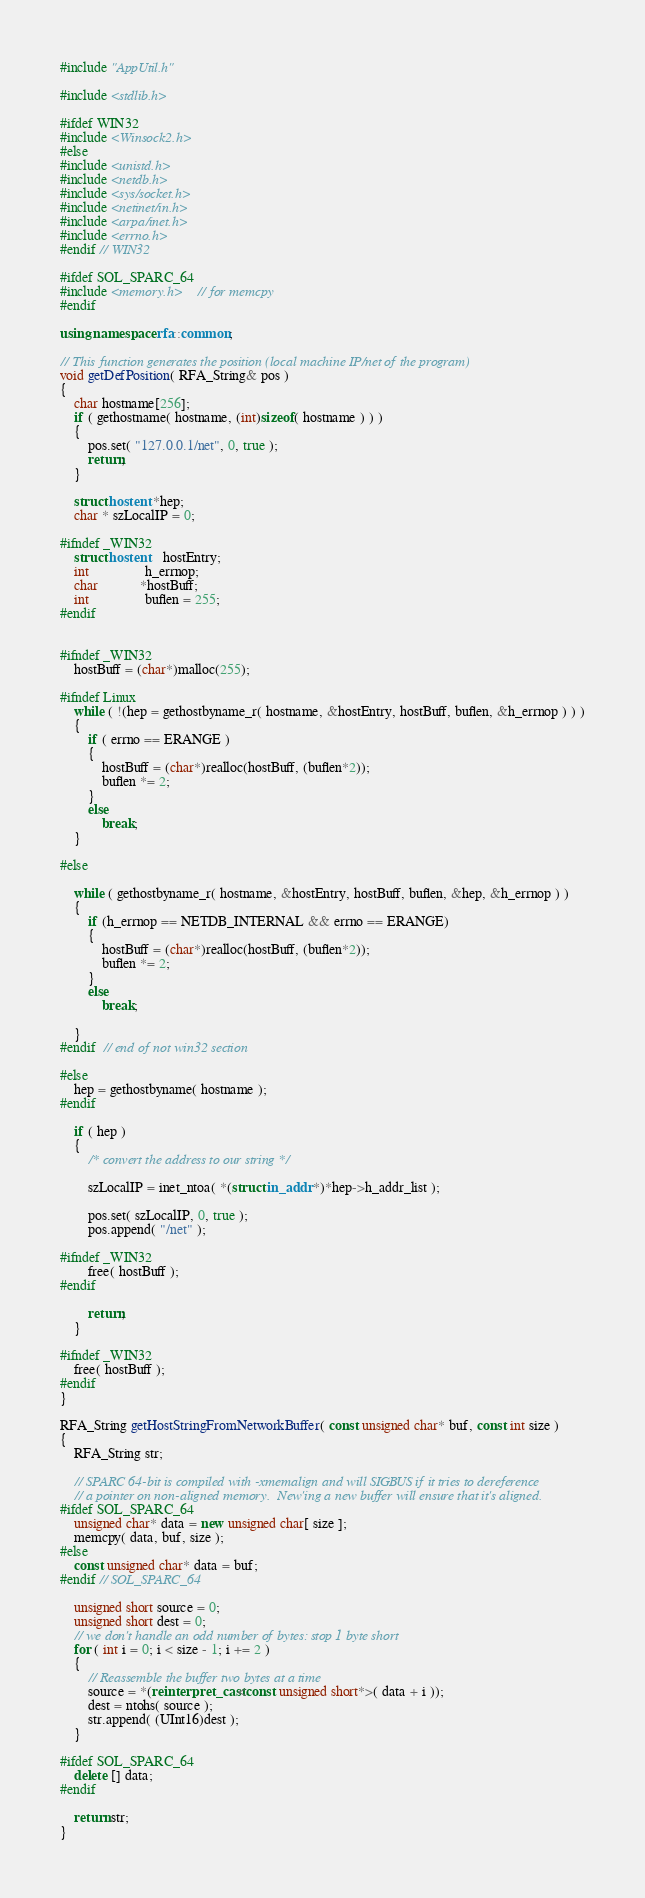Convert code to text. <code><loc_0><loc_0><loc_500><loc_500><_C++_>#include "AppUtil.h"

#include <stdlib.h>

#ifdef WIN32
#include <Winsock2.h>
#else
#include <unistd.h>
#include <netdb.h>
#include <sys/socket.h>
#include <netinet/in.h>
#include <arpa/inet.h>
#include <errno.h>
#endif // WIN32

#ifdef SOL_SPARC_64
#include <memory.h>	// for memcpy
#endif

using namespace rfa::common;

// This function generates the position (local machine IP/net of the program)
void getDefPosition( RFA_String& pos )
{
	char hostname[256];
	if ( gethostname( hostname, (int)sizeof( hostname ) ) )
	{
		pos.set( "127.0.0.1/net", 0, true );
		return;
	}

	struct hostent *hep;
	char * szLocalIP = 0;

#ifndef _WIN32
	struct hostent 	hostEntry;
	int				h_errnop;
	char			*hostBuff;
	int				buflen = 255;
#endif
	

#ifndef _WIN32
	hostBuff = (char*)malloc(255);

#ifndef Linux
	while ( !(hep = gethostbyname_r( hostname, &hostEntry, hostBuff, buflen, &h_errnop ) ) )
	{
		if ( errno == ERANGE )
		{
			hostBuff = (char*)realloc(hostBuff, (buflen*2));
			buflen *= 2;
		}
		else
			break;
	}

#else
	
	while ( gethostbyname_r( hostname, &hostEntry, hostBuff, buflen, &hep, &h_errnop ) )
	{
		if (h_errnop == NETDB_INTERNAL && errno == ERANGE)
		{
			hostBuff = (char*)realloc(hostBuff, (buflen*2));
			buflen *= 2;
		}
		else
			break;

	}
#endif  // end of not win32 section

#else
	hep = gethostbyname( hostname );
#endif

	if ( hep )
	{
		/* convert the address to our string */
			
		szLocalIP = inet_ntoa( *(struct in_addr *)*hep->h_addr_list );
		
		pos.set( szLocalIP, 0, true );
		pos.append( "/net" );
	
#ifndef _WIN32
		free( hostBuff );
#endif

		return;
	}

#ifndef _WIN32
	free( hostBuff );
#endif
}

RFA_String getHostStringFromNetworkBuffer( const unsigned char* buf, const int size )
{
	RFA_String str;

	// SPARC 64-bit is compiled with -xmemalign and will SIGBUS if it tries to dereference
	// a pointer on non-aligned memory.  New'ing a new buffer will ensure that it's aligned.
#ifdef SOL_SPARC_64
	unsigned char* data = new unsigned char[ size ];
	memcpy( data, buf, size );
#else
	const unsigned char* data = buf;
#endif // SOL_SPARC_64

	unsigned short source = 0;
	unsigned short dest = 0;
	// we don't handle an odd number of bytes: stop 1 byte short
	for ( int i = 0; i < size - 1; i += 2 )
	{
		// Reassemble the buffer two bytes at a time
		source = *(reinterpret_cast<const unsigned short*>( data + i ));
		dest = ntohs( source );
		str.append( (UInt16)dest );
	}

#ifdef SOL_SPARC_64
	delete [] data;
#endif

	return str;
}
</code> 